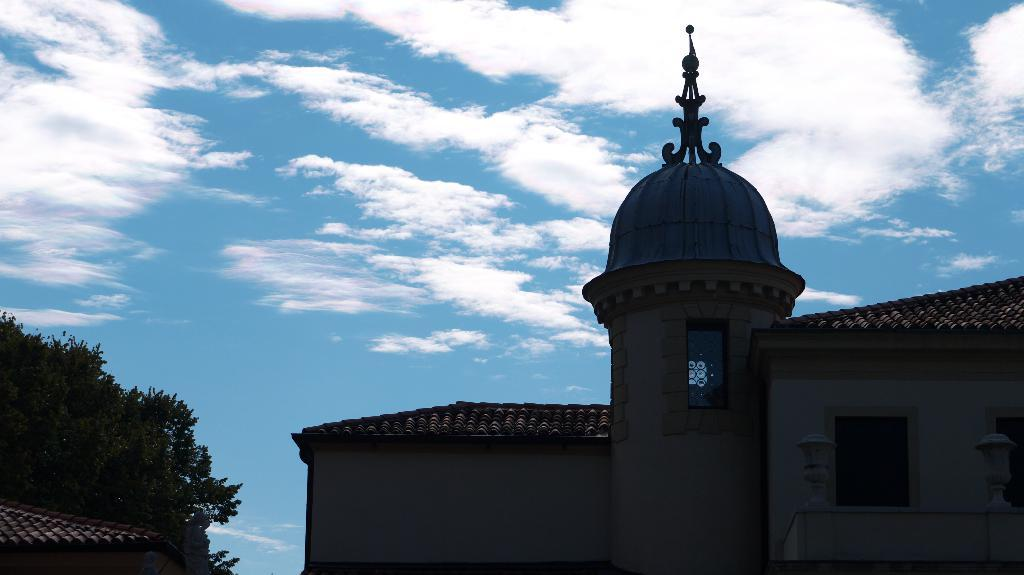What type of structure is featured in the image? There is a historical building in the image. What other elements can be seen in the image besides the building? There are trees in the image. What is visible in the background of the image? The sky is visible in the background of the image. Can you describe the sky in the image? Clouds are present in the sky. What type of brush can be seen in the image? There is no brush present in the image. How many clovers are visible in the image? There are no clovers visible in the image. 